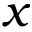<formula> <loc_0><loc_0><loc_500><loc_500>x</formula> 